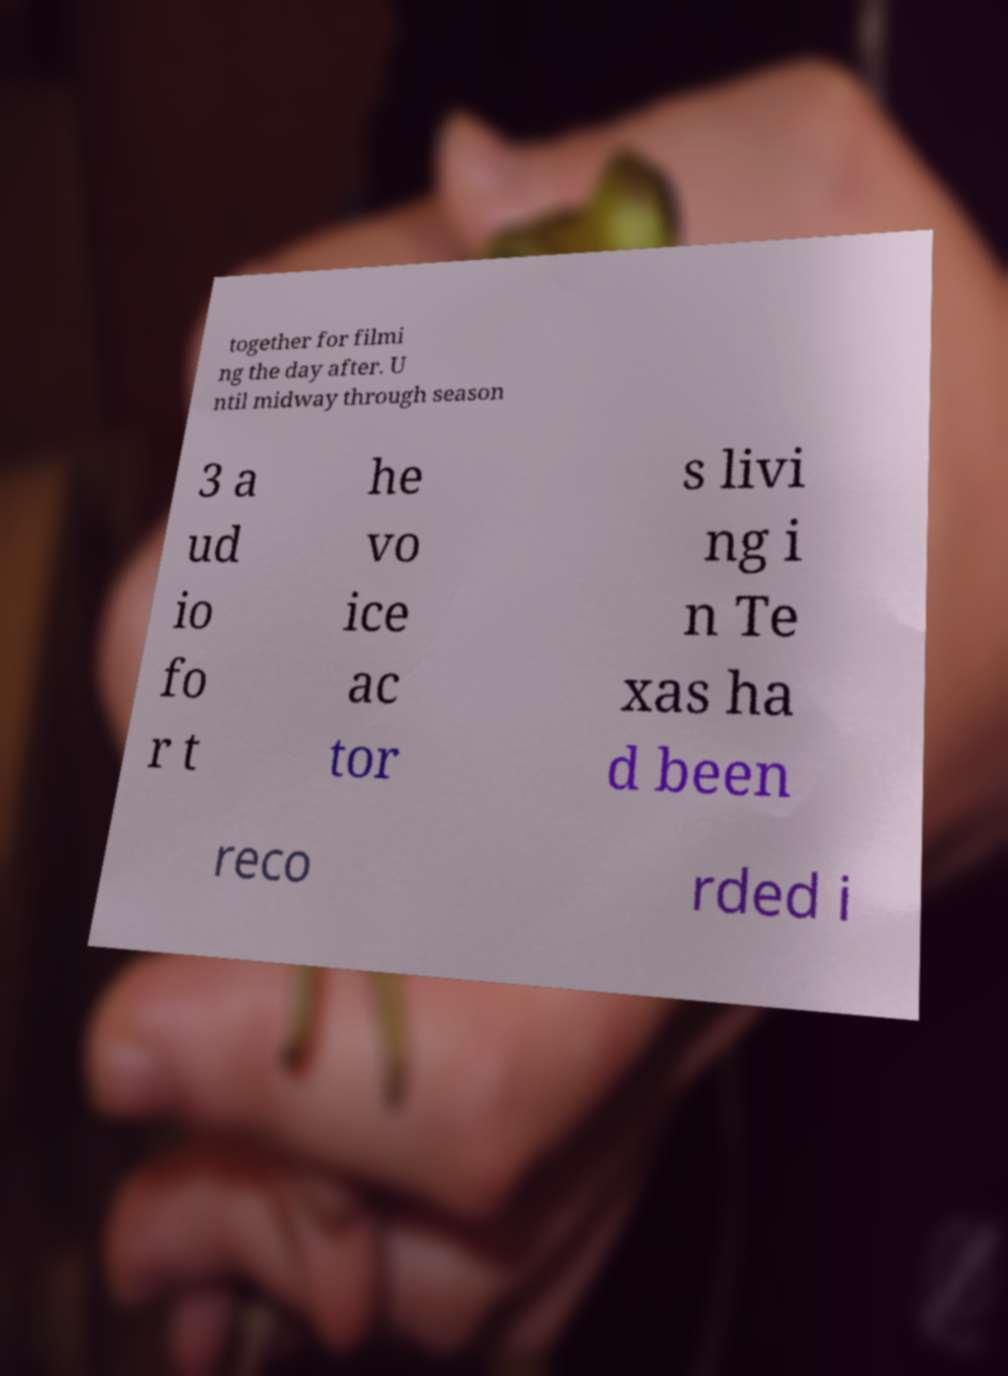Please identify and transcribe the text found in this image. together for filmi ng the day after. U ntil midway through season 3 a ud io fo r t he vo ice ac tor s livi ng i n Te xas ha d been reco rded i 